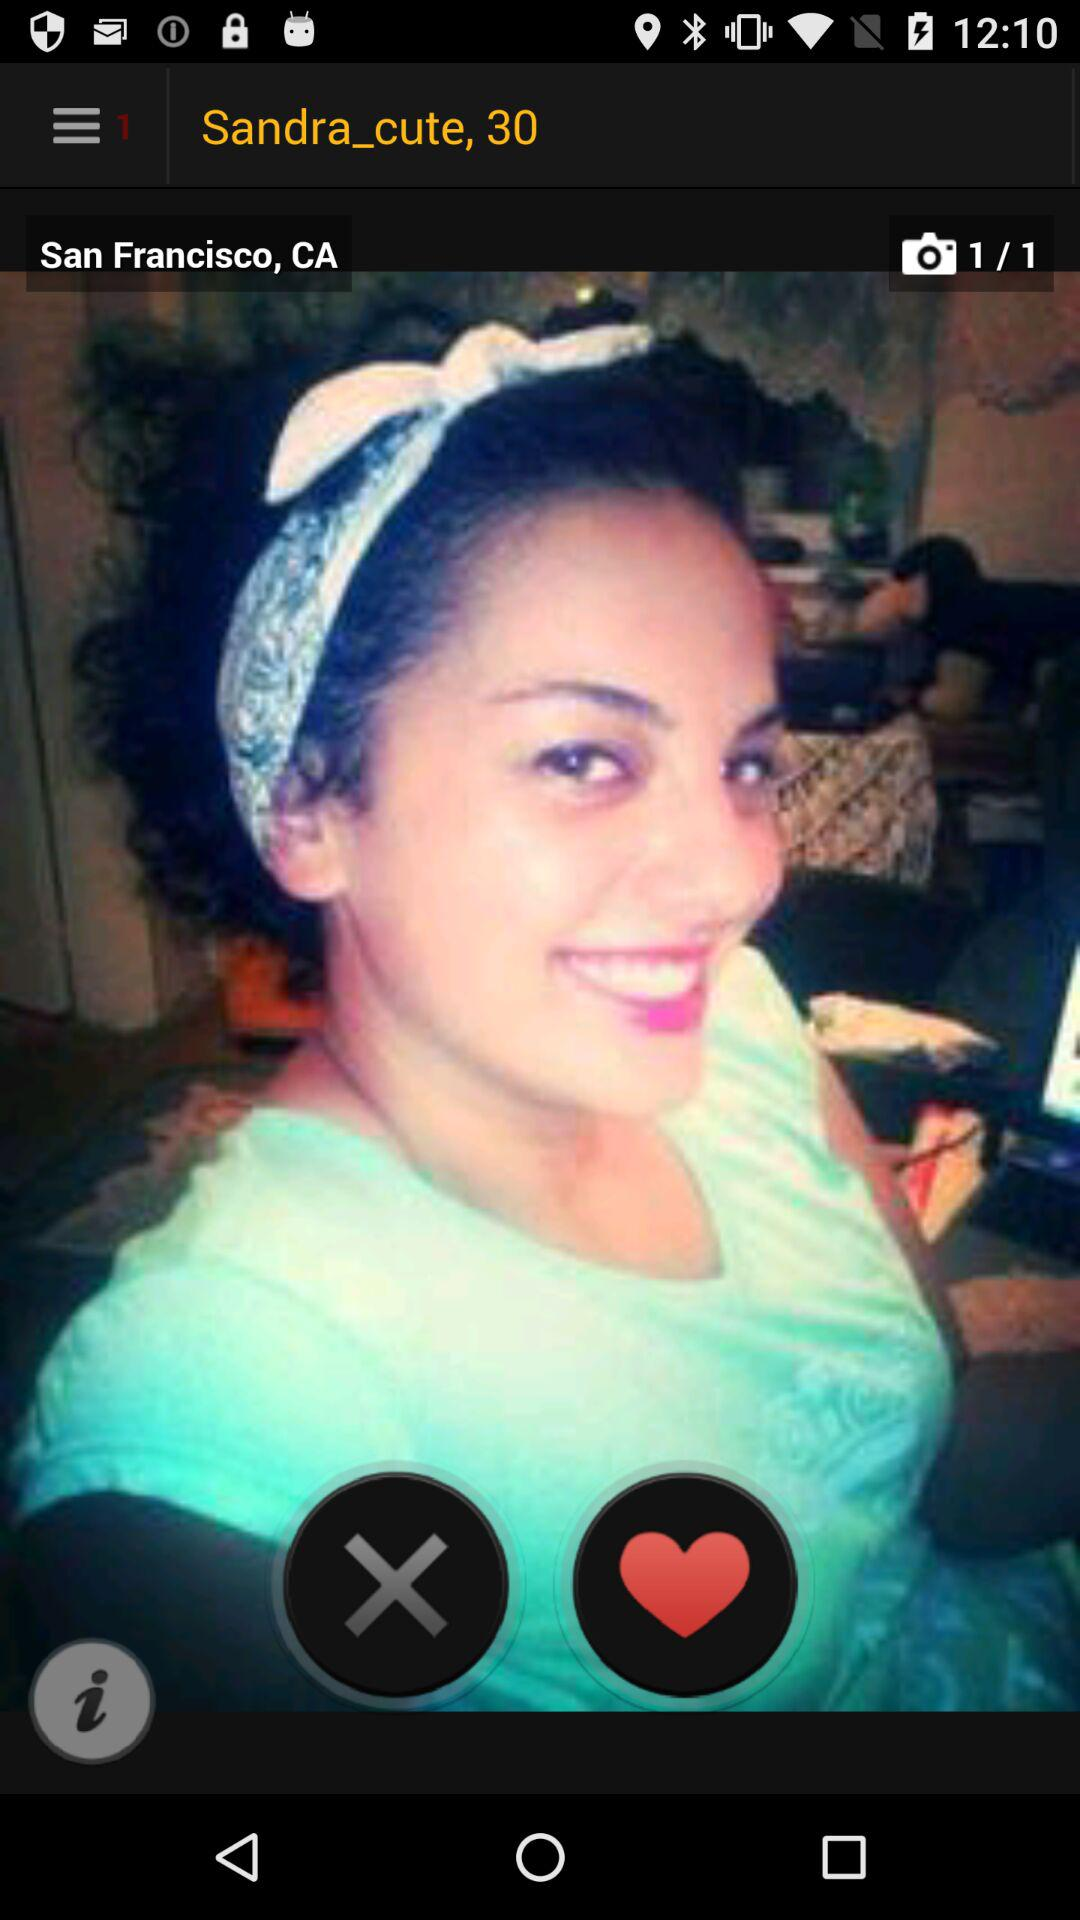At what photo number is the user currently? The user is currently at photo 1. 